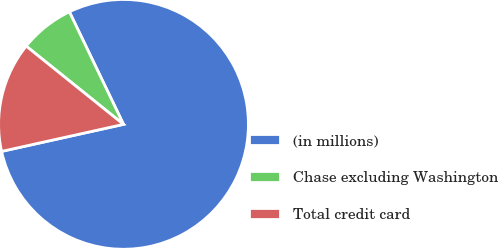Convert chart to OTSL. <chart><loc_0><loc_0><loc_500><loc_500><pie_chart><fcel>(in millions)<fcel>Chase excluding Washington<fcel>Total credit card<nl><fcel>78.67%<fcel>7.09%<fcel>14.25%<nl></chart> 